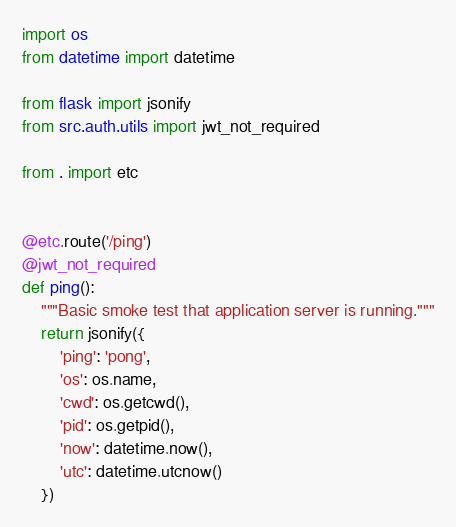<code> <loc_0><loc_0><loc_500><loc_500><_Python_>import os
from datetime import datetime

from flask import jsonify
from src.auth.utils import jwt_not_required

from . import etc


@etc.route('/ping')
@jwt_not_required
def ping():
    """Basic smoke test that application server is running."""
    return jsonify({
        'ping': 'pong',
        'os': os.name,
        'cwd': os.getcwd(),
        'pid': os.getpid(),
        'now': datetime.now(),
        'utc': datetime.utcnow()
    })
</code> 